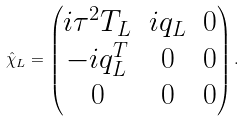Convert formula to latex. <formula><loc_0><loc_0><loc_500><loc_500>\hat { \chi } _ { L } = \begin{pmatrix} i \tau ^ { 2 } T _ { L } & i q _ { L } & 0 \\ - i q _ { L } ^ { T } & 0 & 0 \\ 0 & 0 & 0 \end{pmatrix} .</formula> 